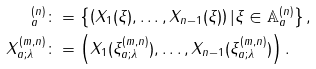<formula> <loc_0><loc_0><loc_500><loc_500>^ { ( n ) } _ { a } & \colon = \left \{ \left ( X _ { 1 } ( \xi ) , \dots , X _ { n - 1 } ( \xi ) \right ) | \xi \in \mathbb { A } ^ { ( n ) } _ { a } \right \} , \\ X ^ { ( m , n ) } _ { a ; \lambda } & \colon = \left ( X _ { 1 } ( \xi ^ { ( m , n ) } _ { a ; \lambda } ) , \dots , X _ { n - 1 } ( \xi ^ { ( m , n ) } _ { a ; \lambda } ) \right ) .</formula> 